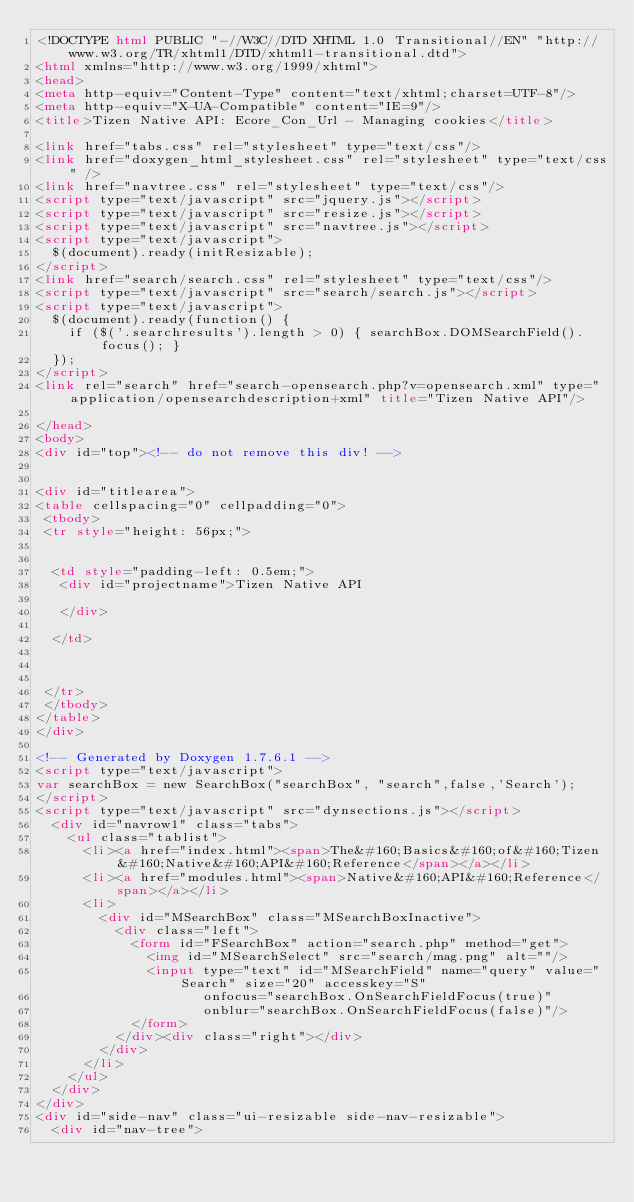<code> <loc_0><loc_0><loc_500><loc_500><_HTML_><!DOCTYPE html PUBLIC "-//W3C//DTD XHTML 1.0 Transitional//EN" "http://www.w3.org/TR/xhtml1/DTD/xhtml1-transitional.dtd">
<html xmlns="http://www.w3.org/1999/xhtml">
<head>
<meta http-equiv="Content-Type" content="text/xhtml;charset=UTF-8"/>
<meta http-equiv="X-UA-Compatible" content="IE=9"/>
<title>Tizen Native API: Ecore_Con_Url - Managing cookies</title>

<link href="tabs.css" rel="stylesheet" type="text/css"/>
<link href="doxygen_html_stylesheet.css" rel="stylesheet" type="text/css" />
<link href="navtree.css" rel="stylesheet" type="text/css"/>
<script type="text/javascript" src="jquery.js"></script>
<script type="text/javascript" src="resize.js"></script>
<script type="text/javascript" src="navtree.js"></script>
<script type="text/javascript">
  $(document).ready(initResizable);
</script>
<link href="search/search.css" rel="stylesheet" type="text/css"/>
<script type="text/javascript" src="search/search.js"></script>
<script type="text/javascript">
  $(document).ready(function() {
    if ($('.searchresults').length > 0) { searchBox.DOMSearchField().focus(); }
  });
</script>
<link rel="search" href="search-opensearch.php?v=opensearch.xml" type="application/opensearchdescription+xml" title="Tizen Native API"/>

</head>
<body>
<div id="top"><!-- do not remove this div! -->


<div id="titlearea">
<table cellspacing="0" cellpadding="0">
 <tbody>
 <tr style="height: 56px;">
  
  
  <td style="padding-left: 0.5em;">
   <div id="projectname">Tizen Native API
   
   </div>
   
  </td>
  
  
  
 </tr>
 </tbody>
</table>
</div>

<!-- Generated by Doxygen 1.7.6.1 -->
<script type="text/javascript">
var searchBox = new SearchBox("searchBox", "search",false,'Search');
</script>
<script type="text/javascript" src="dynsections.js"></script>
  <div id="navrow1" class="tabs">
    <ul class="tablist">
      <li><a href="index.html"><span>The&#160;Basics&#160;of&#160;Tizen&#160;Native&#160;API&#160;Reference</span></a></li>
      <li><a href="modules.html"><span>Native&#160;API&#160;Reference</span></a></li>
      <li>
        <div id="MSearchBox" class="MSearchBoxInactive">
          <div class="left">
            <form id="FSearchBox" action="search.php" method="get">
              <img id="MSearchSelect" src="search/mag.png" alt=""/>
              <input type="text" id="MSearchField" name="query" value="Search" size="20" accesskey="S" 
                     onfocus="searchBox.OnSearchFieldFocus(true)" 
                     onblur="searchBox.OnSearchFieldFocus(false)"/>
            </form>
          </div><div class="right"></div>
        </div>
      </li>
    </ul>
  </div>
</div>
<div id="side-nav" class="ui-resizable side-nav-resizable">
  <div id="nav-tree"></code> 